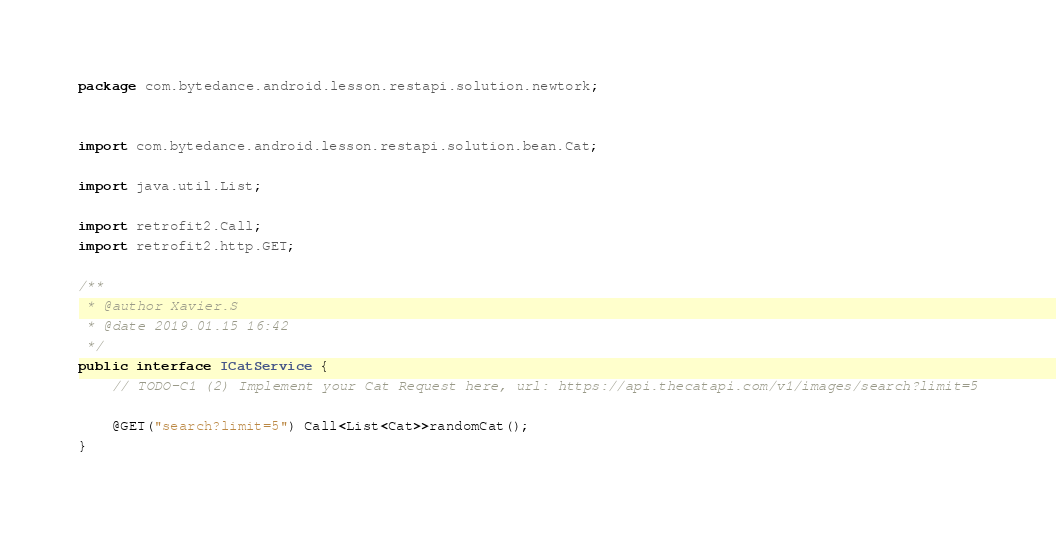<code> <loc_0><loc_0><loc_500><loc_500><_Java_>package com.bytedance.android.lesson.restapi.solution.newtork;


import com.bytedance.android.lesson.restapi.solution.bean.Cat;

import java.util.List;

import retrofit2.Call;
import retrofit2.http.GET;

/**
 * @author Xavier.S
 * @date 2019.01.15 16:42
 */
public interface ICatService {
    // TODO-C1 (2) Implement your Cat Request here, url: https://api.thecatapi.com/v1/images/search?limit=5

    @GET("search?limit=5") Call<List<Cat>>randomCat();
}
</code> 